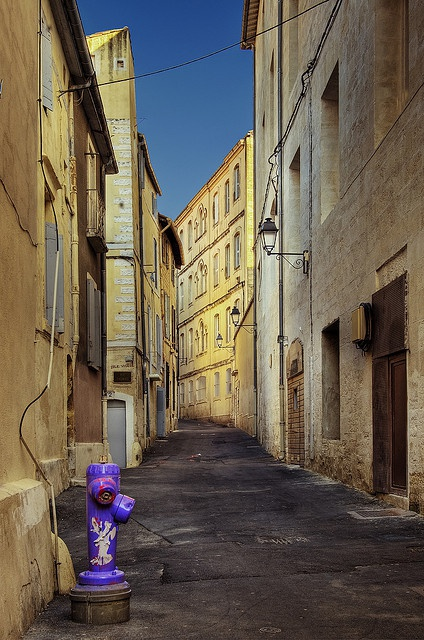Describe the objects in this image and their specific colors. I can see a fire hydrant in olive, navy, darkblue, and black tones in this image. 